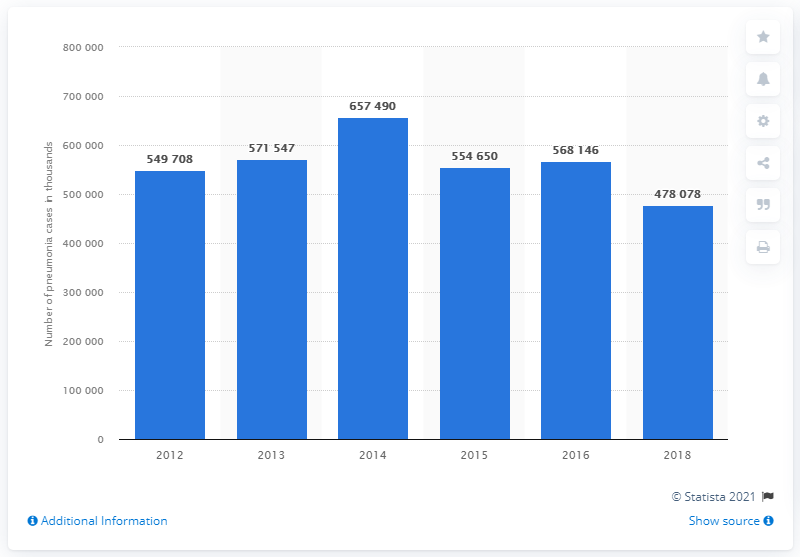Mention a couple of crucial points in this snapshot. In 2018, there were reported to be 478,078 cases of pneumonia in Indonesia. 